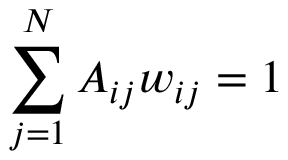<formula> <loc_0><loc_0><loc_500><loc_500>\sum _ { j = 1 } ^ { N } A _ { i j } w _ { i j } = 1</formula> 